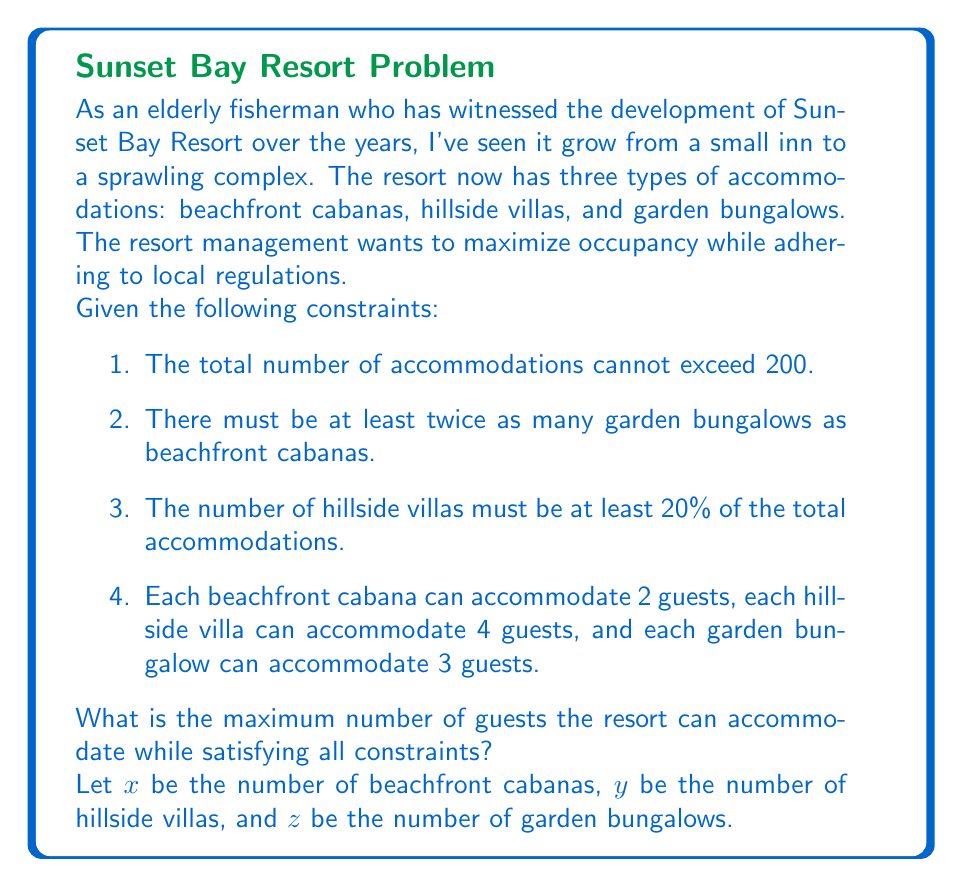Provide a solution to this math problem. To solve this problem, we need to set up a system of inequalities based on the given constraints and then maximize the total number of guests.

1. Total accommodations constraint:
   $x + y + z \leq 200$

2. Relation between garden bungalows and beachfront cabanas:
   $z \geq 2x$

3. Minimum number of hillside villas:
   $y \geq 0.2(x + y + z)$

4. Non-negativity constraints:
   $x \geq 0, y \geq 0, z \geq 0$

Our objective is to maximize the total number of guests:
$\text{Max } 2x + 4y + 3z$

To solve this linear programming problem, we can use the following approach:

1. Recognize that to maximize the total guests, we should use all available accommodations. So, we can change the first inequality to an equality:
   $x + y + z = 200$

2. From the second constraint, we know that $z = 2x$ will give us the minimum number of garden bungalows. Using more than this would reduce the number of other accommodations, which accommodate more guests per unit.

3. Substituting these into the third constraint:
   $y \geq 0.2(x + y + 2x)$
   $y \geq 0.2(3x + y)$
   $0.8y \geq 0.6x$
   $y \geq 0.75x$

4. Now we can express everything in terms of $x$:
   $x + y + z = 200$
   $x + 0.75x + 2x = 200$
   $3.75x = 200$
   $x = 53.33$

5. Since $x$ must be an integer, we round down to 53.

6. Now we can calculate $y$ and $z$:
   $y = 0.75 * 53 = 39.75$, rounded up to 40 to meet the minimum 20% requirement.
   $z = 200 - 53 - 40 = 107$

7. Finally, we can calculate the total number of guests:
   $2(53) + 4(40) + 3(107) = 106 + 160 + 321 = 587$
Answer: The maximum number of guests the resort can accommodate while satisfying all constraints is 587. 